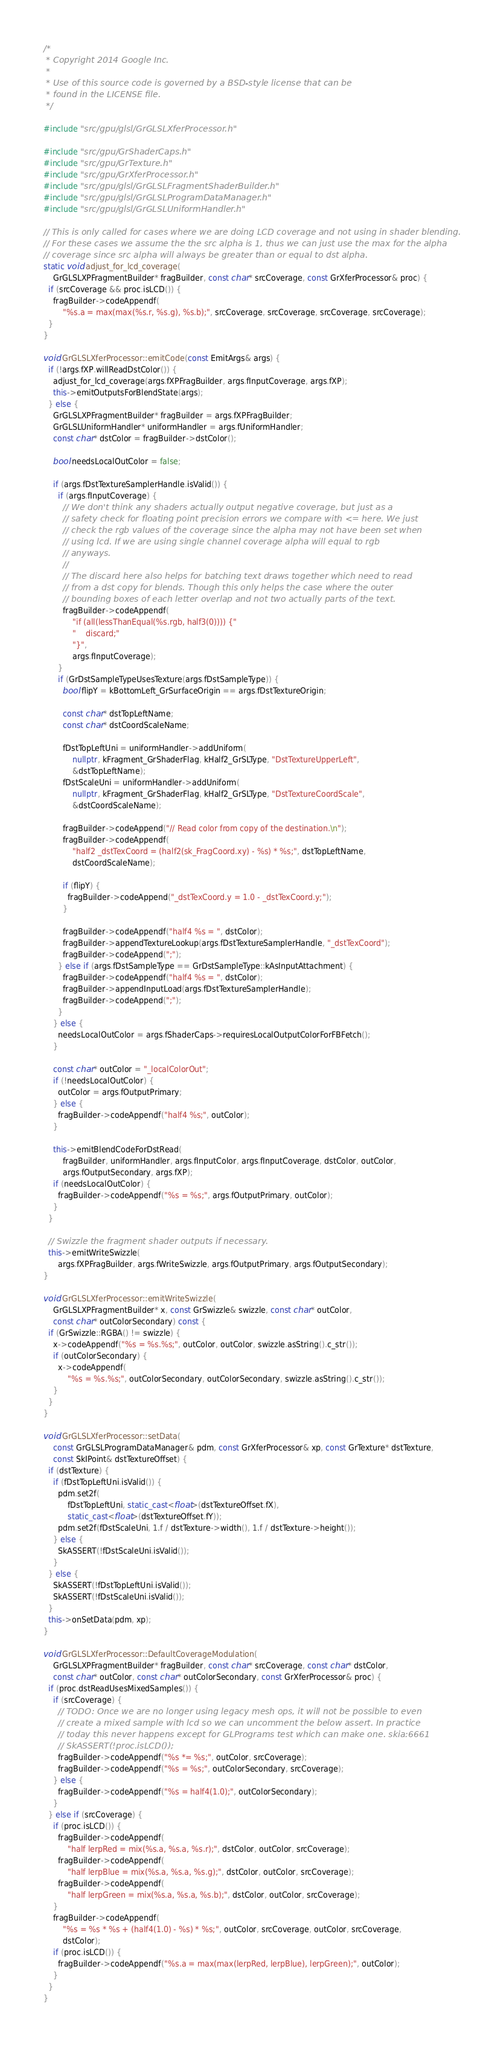<code> <loc_0><loc_0><loc_500><loc_500><_C++_>/*
 * Copyright 2014 Google Inc.
 *
 * Use of this source code is governed by a BSD-style license that can be
 * found in the LICENSE file.
 */

#include "src/gpu/glsl/GrGLSLXferProcessor.h"

#include "src/gpu/GrShaderCaps.h"
#include "src/gpu/GrTexture.h"
#include "src/gpu/GrXferProcessor.h"
#include "src/gpu/glsl/GrGLSLFragmentShaderBuilder.h"
#include "src/gpu/glsl/GrGLSLProgramDataManager.h"
#include "src/gpu/glsl/GrGLSLUniformHandler.h"

// This is only called for cases where we are doing LCD coverage and not using in shader blending.
// For these cases we assume the the src alpha is 1, thus we can just use the max for the alpha
// coverage since src alpha will always be greater than or equal to dst alpha.
static void adjust_for_lcd_coverage(
    GrGLSLXPFragmentBuilder* fragBuilder, const char* srcCoverage, const GrXferProcessor& proc) {
  if (srcCoverage && proc.isLCD()) {
    fragBuilder->codeAppendf(
        "%s.a = max(max(%s.r, %s.g), %s.b);", srcCoverage, srcCoverage, srcCoverage, srcCoverage);
  }
}

void GrGLSLXferProcessor::emitCode(const EmitArgs& args) {
  if (!args.fXP.willReadDstColor()) {
    adjust_for_lcd_coverage(args.fXPFragBuilder, args.fInputCoverage, args.fXP);
    this->emitOutputsForBlendState(args);
  } else {
    GrGLSLXPFragmentBuilder* fragBuilder = args.fXPFragBuilder;
    GrGLSLUniformHandler* uniformHandler = args.fUniformHandler;
    const char* dstColor = fragBuilder->dstColor();

    bool needsLocalOutColor = false;

    if (args.fDstTextureSamplerHandle.isValid()) {
      if (args.fInputCoverage) {
        // We don't think any shaders actually output negative coverage, but just as a
        // safety check for floating point precision errors we compare with <= here. We just
        // check the rgb values of the coverage since the alpha may not have been set when
        // using lcd. If we are using single channel coverage alpha will equal to rgb
        // anyways.
        //
        // The discard here also helps for batching text draws together which need to read
        // from a dst copy for blends. Though this only helps the case where the outer
        // bounding boxes of each letter overlap and not two actually parts of the text.
        fragBuilder->codeAppendf(
            "if (all(lessThanEqual(%s.rgb, half3(0)))) {"
            "    discard;"
            "}",
            args.fInputCoverage);
      }
      if (GrDstSampleTypeUsesTexture(args.fDstSampleType)) {
        bool flipY = kBottomLeft_GrSurfaceOrigin == args.fDstTextureOrigin;

        const char* dstTopLeftName;
        const char* dstCoordScaleName;

        fDstTopLeftUni = uniformHandler->addUniform(
            nullptr, kFragment_GrShaderFlag, kHalf2_GrSLType, "DstTextureUpperLeft",
            &dstTopLeftName);
        fDstScaleUni = uniformHandler->addUniform(
            nullptr, kFragment_GrShaderFlag, kHalf2_GrSLType, "DstTextureCoordScale",
            &dstCoordScaleName);

        fragBuilder->codeAppend("// Read color from copy of the destination.\n");
        fragBuilder->codeAppendf(
            "half2 _dstTexCoord = (half2(sk_FragCoord.xy) - %s) * %s;", dstTopLeftName,
            dstCoordScaleName);

        if (flipY) {
          fragBuilder->codeAppend("_dstTexCoord.y = 1.0 - _dstTexCoord.y;");
        }

        fragBuilder->codeAppendf("half4 %s = ", dstColor);
        fragBuilder->appendTextureLookup(args.fDstTextureSamplerHandle, "_dstTexCoord");
        fragBuilder->codeAppend(";");
      } else if (args.fDstSampleType == GrDstSampleType::kAsInputAttachment) {
        fragBuilder->codeAppendf("half4 %s = ", dstColor);
        fragBuilder->appendInputLoad(args.fDstTextureSamplerHandle);
        fragBuilder->codeAppend(";");
      }
    } else {
      needsLocalOutColor = args.fShaderCaps->requiresLocalOutputColorForFBFetch();
    }

    const char* outColor = "_localColorOut";
    if (!needsLocalOutColor) {
      outColor = args.fOutputPrimary;
    } else {
      fragBuilder->codeAppendf("half4 %s;", outColor);
    }

    this->emitBlendCodeForDstRead(
        fragBuilder, uniformHandler, args.fInputColor, args.fInputCoverage, dstColor, outColor,
        args.fOutputSecondary, args.fXP);
    if (needsLocalOutColor) {
      fragBuilder->codeAppendf("%s = %s;", args.fOutputPrimary, outColor);
    }
  }

  // Swizzle the fragment shader outputs if necessary.
  this->emitWriteSwizzle(
      args.fXPFragBuilder, args.fWriteSwizzle, args.fOutputPrimary, args.fOutputSecondary);
}

void GrGLSLXferProcessor::emitWriteSwizzle(
    GrGLSLXPFragmentBuilder* x, const GrSwizzle& swizzle, const char* outColor,
    const char* outColorSecondary) const {
  if (GrSwizzle::RGBA() != swizzle) {
    x->codeAppendf("%s = %s.%s;", outColor, outColor, swizzle.asString().c_str());
    if (outColorSecondary) {
      x->codeAppendf(
          "%s = %s.%s;", outColorSecondary, outColorSecondary, swizzle.asString().c_str());
    }
  }
}

void GrGLSLXferProcessor::setData(
    const GrGLSLProgramDataManager& pdm, const GrXferProcessor& xp, const GrTexture* dstTexture,
    const SkIPoint& dstTextureOffset) {
  if (dstTexture) {
    if (fDstTopLeftUni.isValid()) {
      pdm.set2f(
          fDstTopLeftUni, static_cast<float>(dstTextureOffset.fX),
          static_cast<float>(dstTextureOffset.fY));
      pdm.set2f(fDstScaleUni, 1.f / dstTexture->width(), 1.f / dstTexture->height());
    } else {
      SkASSERT(!fDstScaleUni.isValid());
    }
  } else {
    SkASSERT(!fDstTopLeftUni.isValid());
    SkASSERT(!fDstScaleUni.isValid());
  }
  this->onSetData(pdm, xp);
}

void GrGLSLXferProcessor::DefaultCoverageModulation(
    GrGLSLXPFragmentBuilder* fragBuilder, const char* srcCoverage, const char* dstColor,
    const char* outColor, const char* outColorSecondary, const GrXferProcessor& proc) {
  if (proc.dstReadUsesMixedSamples()) {
    if (srcCoverage) {
      // TODO: Once we are no longer using legacy mesh ops, it will not be possible to even
      // create a mixed sample with lcd so we can uncomment the below assert. In practice
      // today this never happens except for GLPrograms test which can make one. skia:6661
      // SkASSERT(!proc.isLCD());
      fragBuilder->codeAppendf("%s *= %s;", outColor, srcCoverage);
      fragBuilder->codeAppendf("%s = %s;", outColorSecondary, srcCoverage);
    } else {
      fragBuilder->codeAppendf("%s = half4(1.0);", outColorSecondary);
    }
  } else if (srcCoverage) {
    if (proc.isLCD()) {
      fragBuilder->codeAppendf(
          "half lerpRed = mix(%s.a, %s.a, %s.r);", dstColor, outColor, srcCoverage);
      fragBuilder->codeAppendf(
          "half lerpBlue = mix(%s.a, %s.a, %s.g);", dstColor, outColor, srcCoverage);
      fragBuilder->codeAppendf(
          "half lerpGreen = mix(%s.a, %s.a, %s.b);", dstColor, outColor, srcCoverage);
    }
    fragBuilder->codeAppendf(
        "%s = %s * %s + (half4(1.0) - %s) * %s;", outColor, srcCoverage, outColor, srcCoverage,
        dstColor);
    if (proc.isLCD()) {
      fragBuilder->codeAppendf("%s.a = max(max(lerpRed, lerpBlue), lerpGreen);", outColor);
    }
  }
}
</code> 